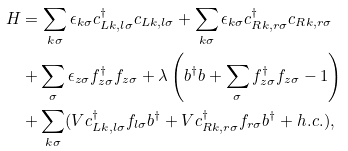<formula> <loc_0><loc_0><loc_500><loc_500>H & = \sum _ { k \sigma } \epsilon _ { k \sigma } c _ { L k , l \sigma } ^ { \dagger } c _ { L k , l \sigma } + \sum _ { k \sigma } \epsilon _ { k \sigma } c _ { R k , r \sigma } ^ { \dagger } c _ { R k , r \sigma } \\ & + \sum _ { \sigma } \epsilon _ { z \sigma } f _ { z \sigma } ^ { \dagger } f _ { z \sigma } + \lambda \left ( b ^ { \dagger } b + \sum _ { \sigma } f _ { z \sigma } ^ { \dagger } f _ { z \sigma } - 1 \right ) \\ & + \sum _ { k \sigma } ( V c _ { L k , l \sigma } ^ { \dagger } f _ { l \sigma } b ^ { \dagger } + V c _ { R k , r \sigma } ^ { \dagger } f _ { r \sigma } b ^ { \dagger } + h . c . ) ,</formula> 